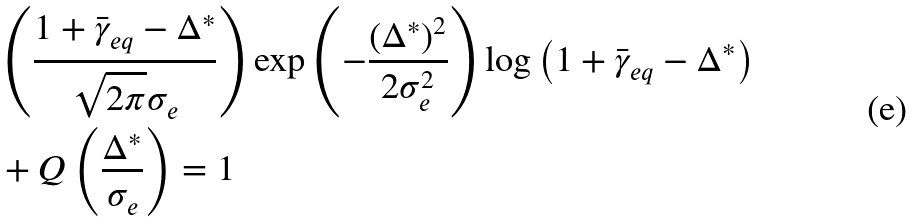<formula> <loc_0><loc_0><loc_500><loc_500>& \left ( \frac { 1 + \bar { \gamma } _ { e q } - \Delta ^ { * } } { \sqrt { 2 \pi } \sigma _ { e } } \right ) \exp \left ( - \frac { ( \Delta ^ { * } ) ^ { 2 } } { 2 \sigma _ { e } ^ { 2 } } \right ) \log \left ( 1 + \bar { \gamma } _ { e q } - \Delta ^ { * } \right ) \\ & + Q \left ( \frac { \Delta ^ { * } } { \sigma _ { e } } \right ) = 1</formula> 